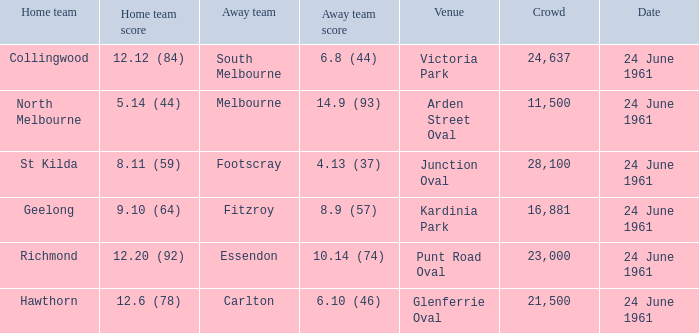What was the home team's score at the game attended by more than 24,637? 8.11 (59). 